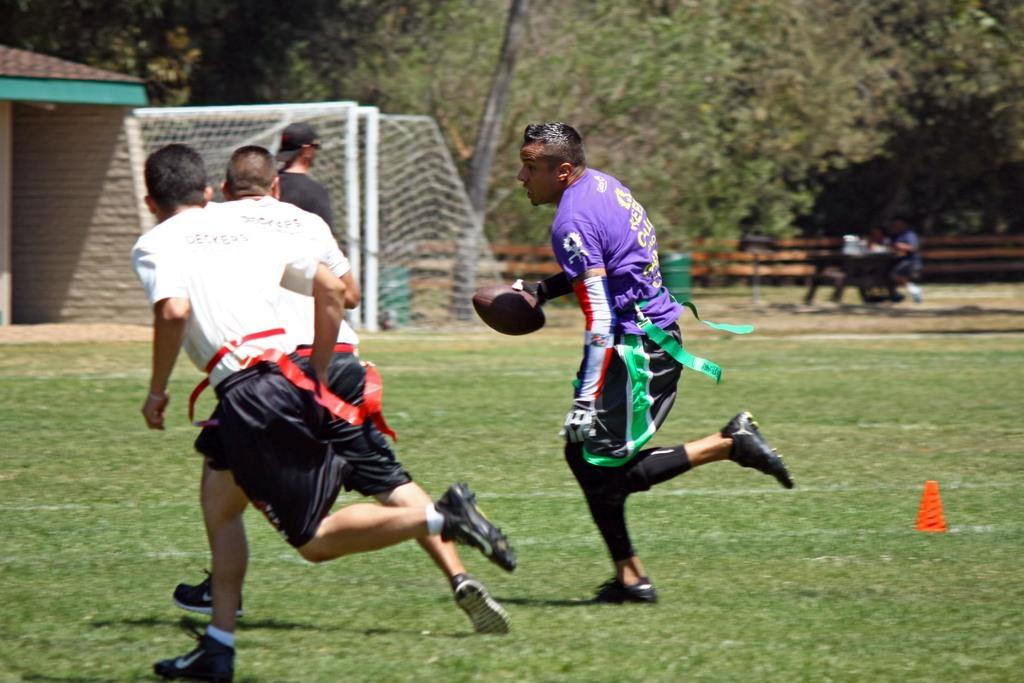How many players are in the image? There are multiple players in the image. What are the players doing in the image? The players are running on a ground. Which player is holding an object in the image? One of the players is holding a ball. What can be seen in the background of the image? There are trees and a net visible in the background. What type of condition is the nest in the image? There is no nest present in the image. How many buckets are visible in the image? There are no buckets visible in the image. 